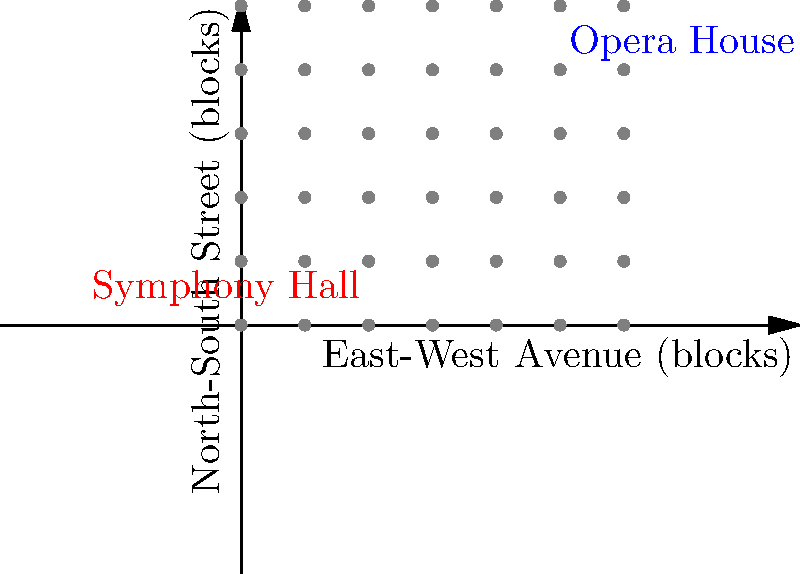You're planning to attend concerts at both Symphony Hall and the Opera House in your city. Using the map provided, where each unit represents one city block, calculate the shortest walking distance between these two venues. Assume you can only walk along the grid lines. To find the shortest walking distance between Symphony Hall and the Opera House, we need to count the number of blocks traveled horizontally and vertically. This method is known as the Manhattan distance.

Step 1: Identify the coordinates
- Symphony Hall is at (2,1)
- Opera House is at (5,4)

Step 2: Calculate the horizontal distance
- East-West distance = 5 - 2 = 3 blocks

Step 3: Calculate the vertical distance
- North-South distance = 4 - 1 = 3 blocks

Step 4: Sum the horizontal and vertical distances
- Total distance = Horizontal distance + Vertical distance
- Total distance = 3 + 3 = 6 blocks

Therefore, the shortest walking distance between Symphony Hall and the Opera House is 6 blocks.
Answer: 6 blocks 